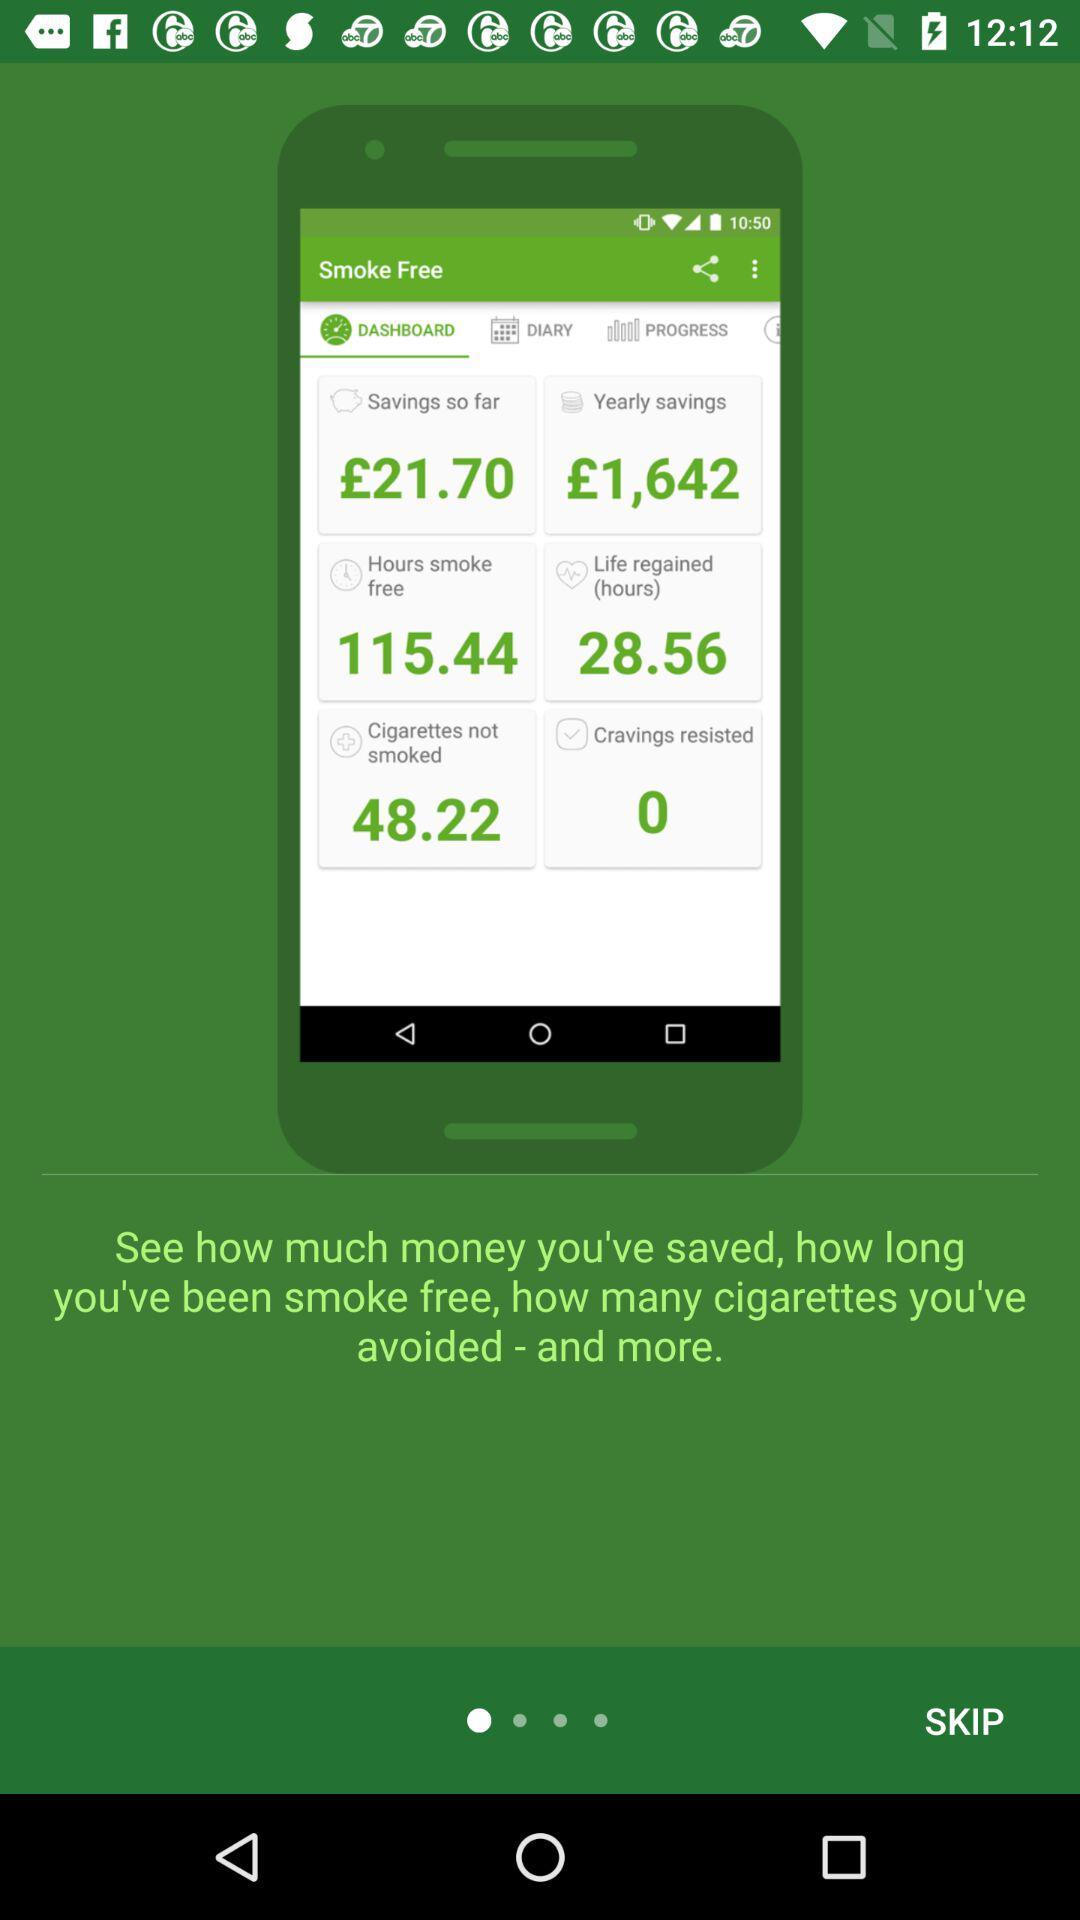How many hours are smoke-free? The smoke-free hours are 115.44. 